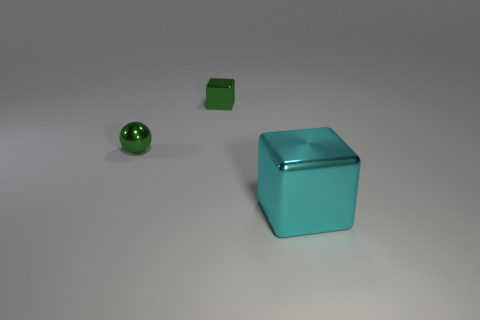Add 1 large purple balls. How many objects exist? 4 Subtract all cubes. How many objects are left? 1 Subtract 0 yellow cubes. How many objects are left? 3 Subtract all small things. Subtract all tiny metal cubes. How many objects are left? 0 Add 1 small green metal things. How many small green metal things are left? 3 Add 3 green things. How many green things exist? 5 